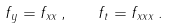<formula> <loc_0><loc_0><loc_500><loc_500>f _ { y } = f _ { x x } \, , \quad f _ { t } = f _ { x x x } \, .</formula> 